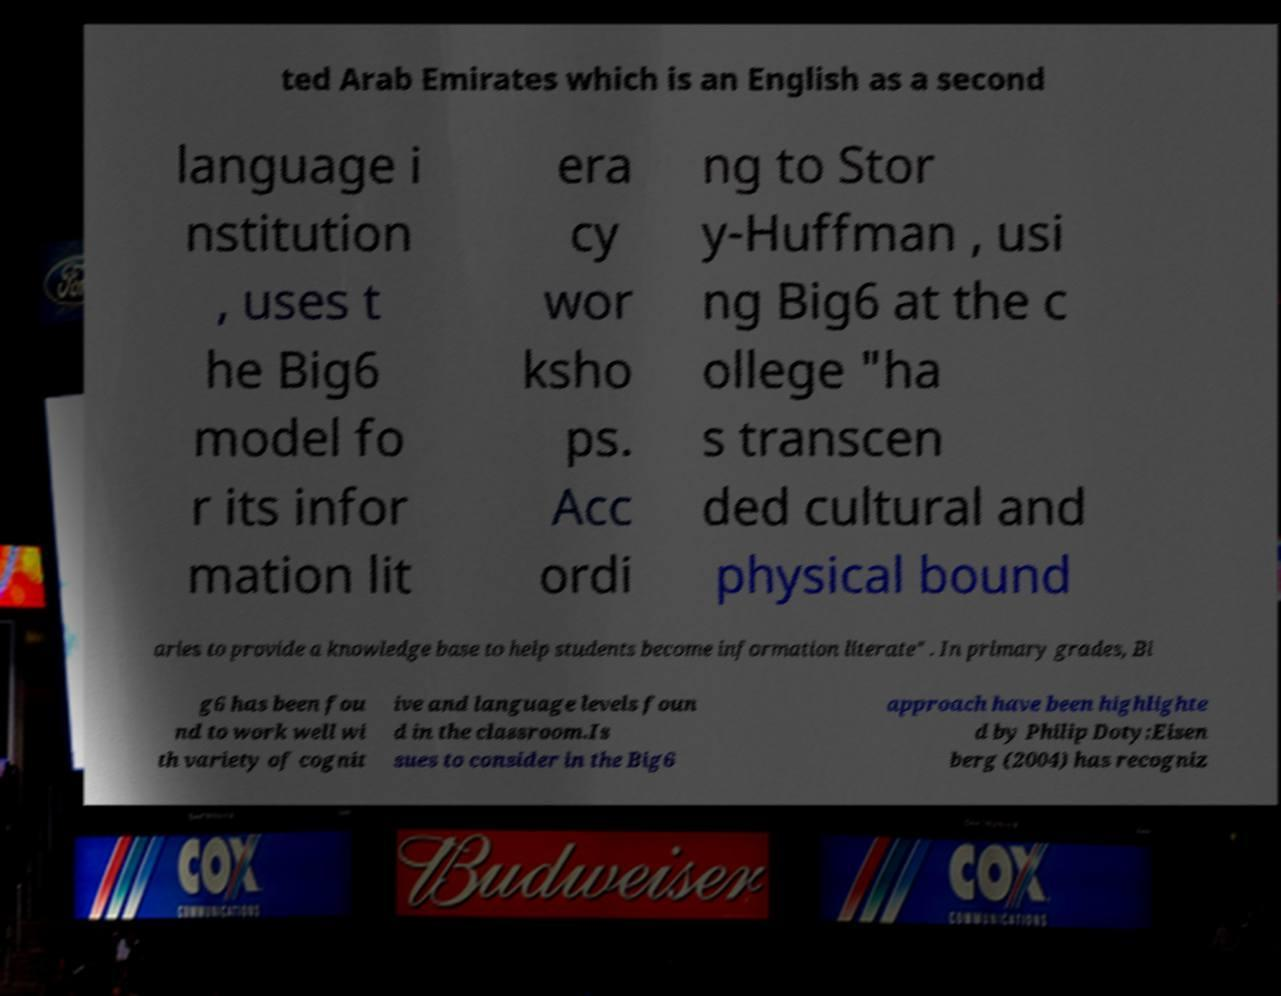What messages or text are displayed in this image? I need them in a readable, typed format. ted Arab Emirates which is an English as a second language i nstitution , uses t he Big6 model fo r its infor mation lit era cy wor ksho ps. Acc ordi ng to Stor y-Huffman , usi ng Big6 at the c ollege "ha s transcen ded cultural and physical bound aries to provide a knowledge base to help students become information literate" . In primary grades, Bi g6 has been fou nd to work well wi th variety of cognit ive and language levels foun d in the classroom.Is sues to consider in the Big6 approach have been highlighte d by Philip Doty:Eisen berg (2004) has recogniz 